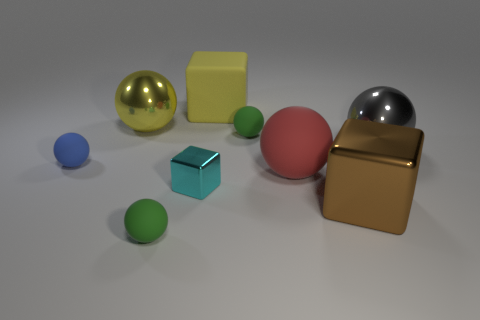What is the mood or atmosphere conveyed by this image? The image conveys a serene, almost clinical atmosphere with its clean composition and balanced placement of objects. There's a sense of order and calmness due to the absence of any human presence, and the choice of soft, ambient lighting further enhances the tranquil mood. 